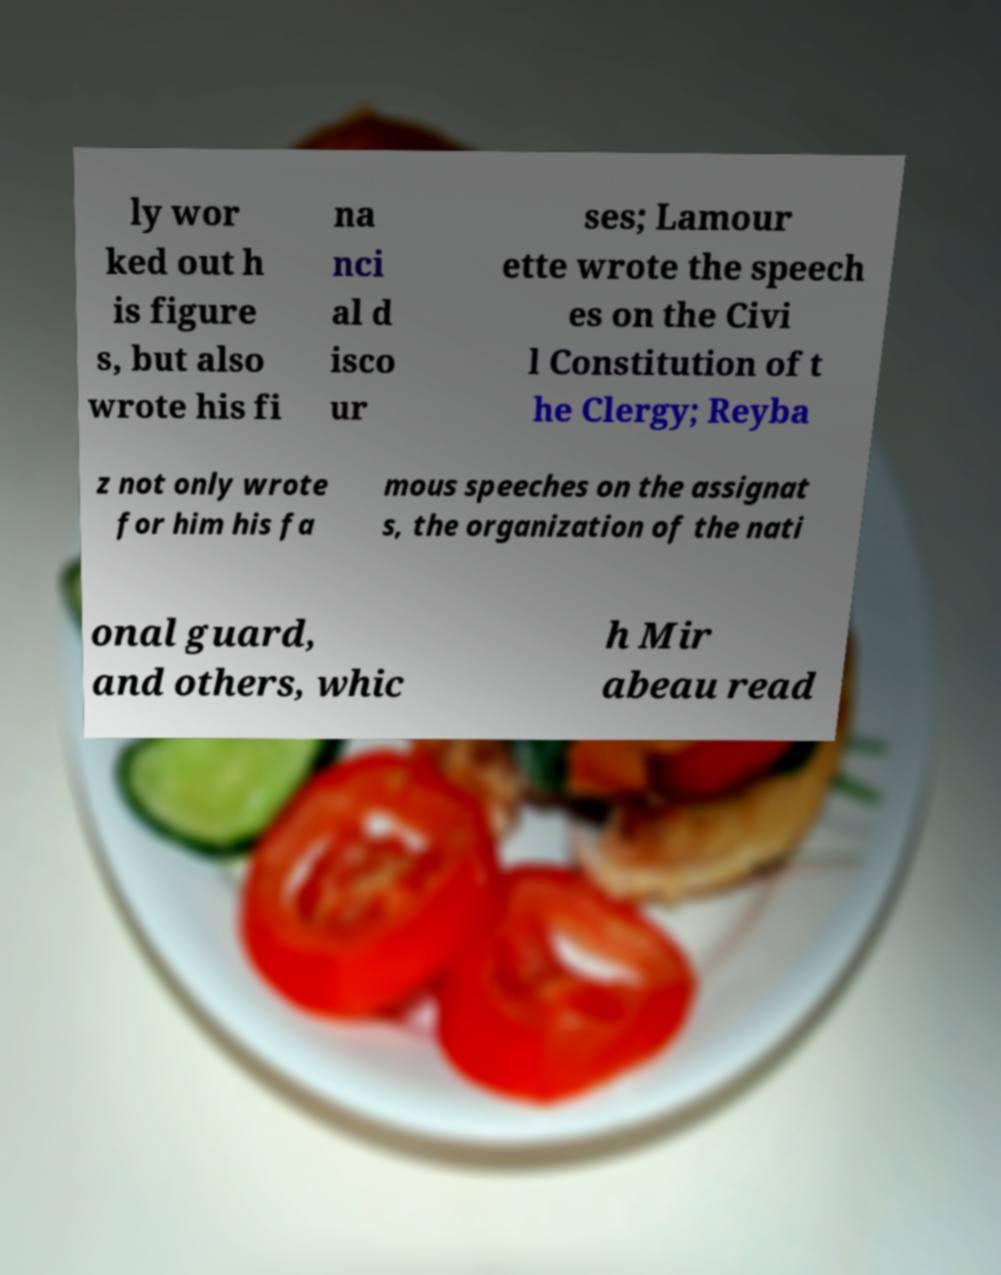Please read and relay the text visible in this image. What does it say? ly wor ked out h is figure s, but also wrote his fi na nci al d isco ur ses; Lamour ette wrote the speech es on the Civi l Constitution of t he Clergy; Reyba z not only wrote for him his fa mous speeches on the assignat s, the organization of the nati onal guard, and others, whic h Mir abeau read 